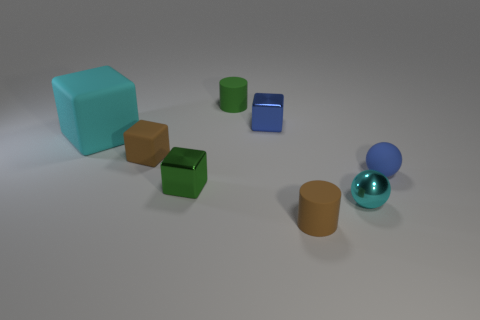Add 1 big things. How many objects exist? 9 Subtract all cylinders. How many objects are left? 6 Add 1 small matte blocks. How many small matte blocks are left? 2 Add 8 cylinders. How many cylinders exist? 10 Subtract 0 purple cubes. How many objects are left? 8 Subtract all tiny cyan matte cubes. Subtract all tiny rubber spheres. How many objects are left? 7 